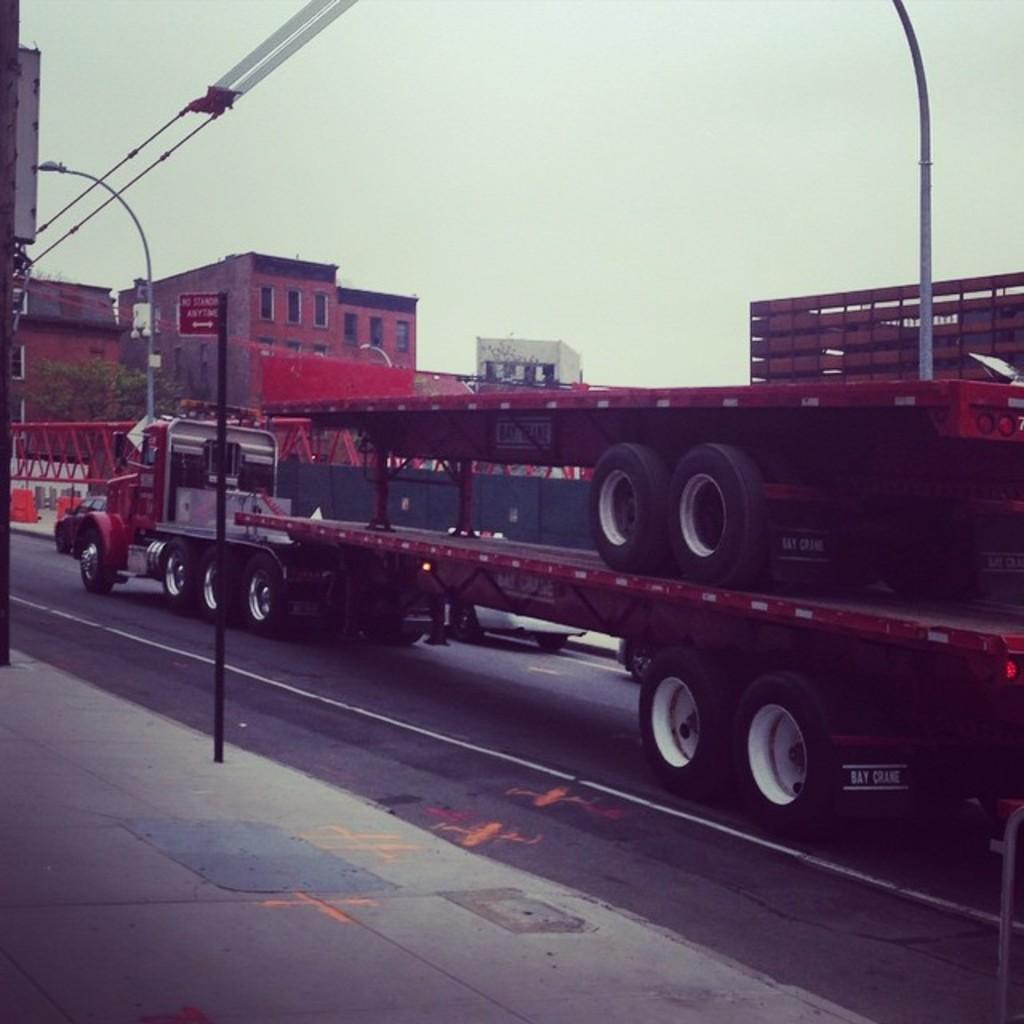What structures can be seen in the image? There are poles and buildings visible in the image. What vehicle is present on the road in the image? There is a truck on the road in the image. What type of vegetation is visible behind the truck? There are trees visible behind the truck. What else can be seen in the background of the image? Buildings and the sky are visible in the image. What type of ear is visible on the queen in the image? There is no queen or ear present in the image. How is the coal being transported in the image? There is no coal present in the image. 